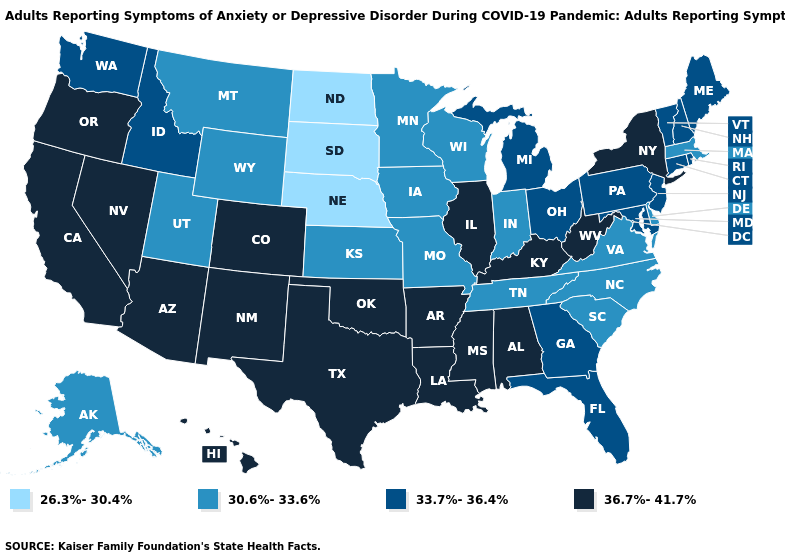What is the value of Colorado?
Give a very brief answer. 36.7%-41.7%. Name the states that have a value in the range 30.6%-33.6%?
Quick response, please. Alaska, Delaware, Indiana, Iowa, Kansas, Massachusetts, Minnesota, Missouri, Montana, North Carolina, South Carolina, Tennessee, Utah, Virginia, Wisconsin, Wyoming. What is the highest value in states that border Maryland?
Keep it brief. 36.7%-41.7%. What is the value of Louisiana?
Concise answer only. 36.7%-41.7%. Does Montana have a higher value than Pennsylvania?
Be succinct. No. Among the states that border Missouri , which have the lowest value?
Answer briefly. Nebraska. Name the states that have a value in the range 26.3%-30.4%?
Short answer required. Nebraska, North Dakota, South Dakota. Does the map have missing data?
Short answer required. No. Name the states that have a value in the range 36.7%-41.7%?
Write a very short answer. Alabama, Arizona, Arkansas, California, Colorado, Hawaii, Illinois, Kentucky, Louisiana, Mississippi, Nevada, New Mexico, New York, Oklahoma, Oregon, Texas, West Virginia. Does Pennsylvania have the same value as Mississippi?
Be succinct. No. Does the map have missing data?
Be succinct. No. What is the value of Iowa?
Concise answer only. 30.6%-33.6%. What is the value of Texas?
Concise answer only. 36.7%-41.7%. What is the value of South Carolina?
Short answer required. 30.6%-33.6%. What is the value of Utah?
Quick response, please. 30.6%-33.6%. 